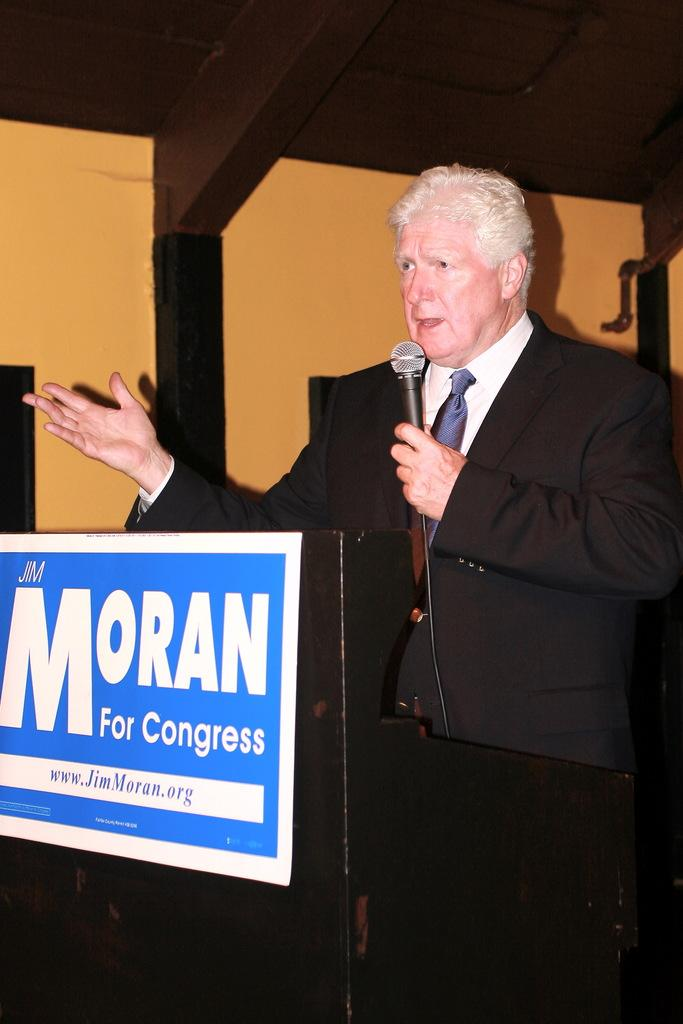Who is the main subject in the image? There is a man in the image. What is the man wearing? The man is wearing a black blazer. What is the man holding in his hand? The man is holding a microphone in his hand. What might the man be doing in the image? The man appears to be talking. What else can be seen in the image? There is a board in the image. What type of drug is the man taking in the image? There is no indication of any drug in the image; the man is holding a microphone and appears to be talking. 